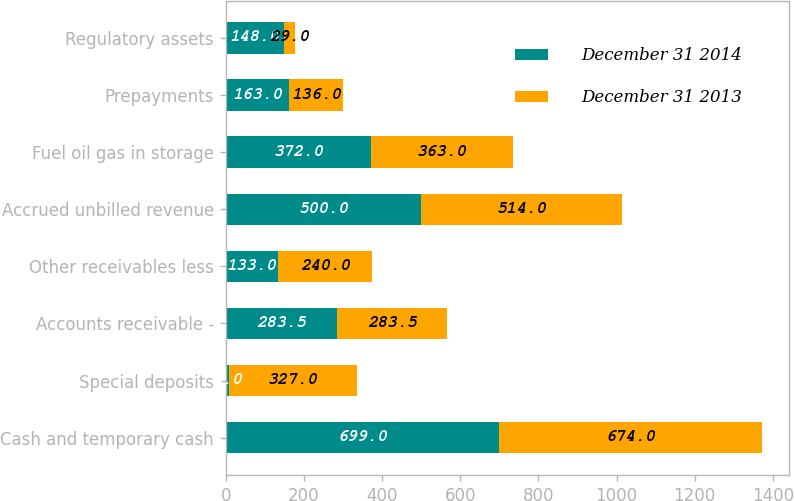Convert chart. <chart><loc_0><loc_0><loc_500><loc_500><stacked_bar_chart><ecel><fcel>Cash and temporary cash<fcel>Special deposits<fcel>Accounts receivable -<fcel>Other receivables less<fcel>Accrued unbilled revenue<fcel>Fuel oil gas in storage<fcel>Prepayments<fcel>Regulatory assets<nl><fcel>December 31 2014<fcel>699<fcel>8<fcel>283.5<fcel>133<fcel>500<fcel>372<fcel>163<fcel>148<nl><fcel>December 31 2013<fcel>674<fcel>327<fcel>283.5<fcel>240<fcel>514<fcel>363<fcel>136<fcel>29<nl></chart> 